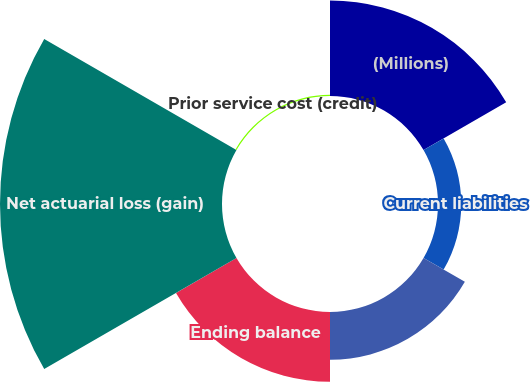<chart> <loc_0><loc_0><loc_500><loc_500><pie_chart><fcel>(Millions)<fcel>Current liabilities<fcel>Non-current liabilities<fcel>Ending balance<fcel>Net actuarial loss (gain)<fcel>Prior service cost (credit)<nl><fcel>20.78%<fcel>5.06%<fcel>10.39%<fcel>15.2%<fcel>48.33%<fcel>0.25%<nl></chart> 